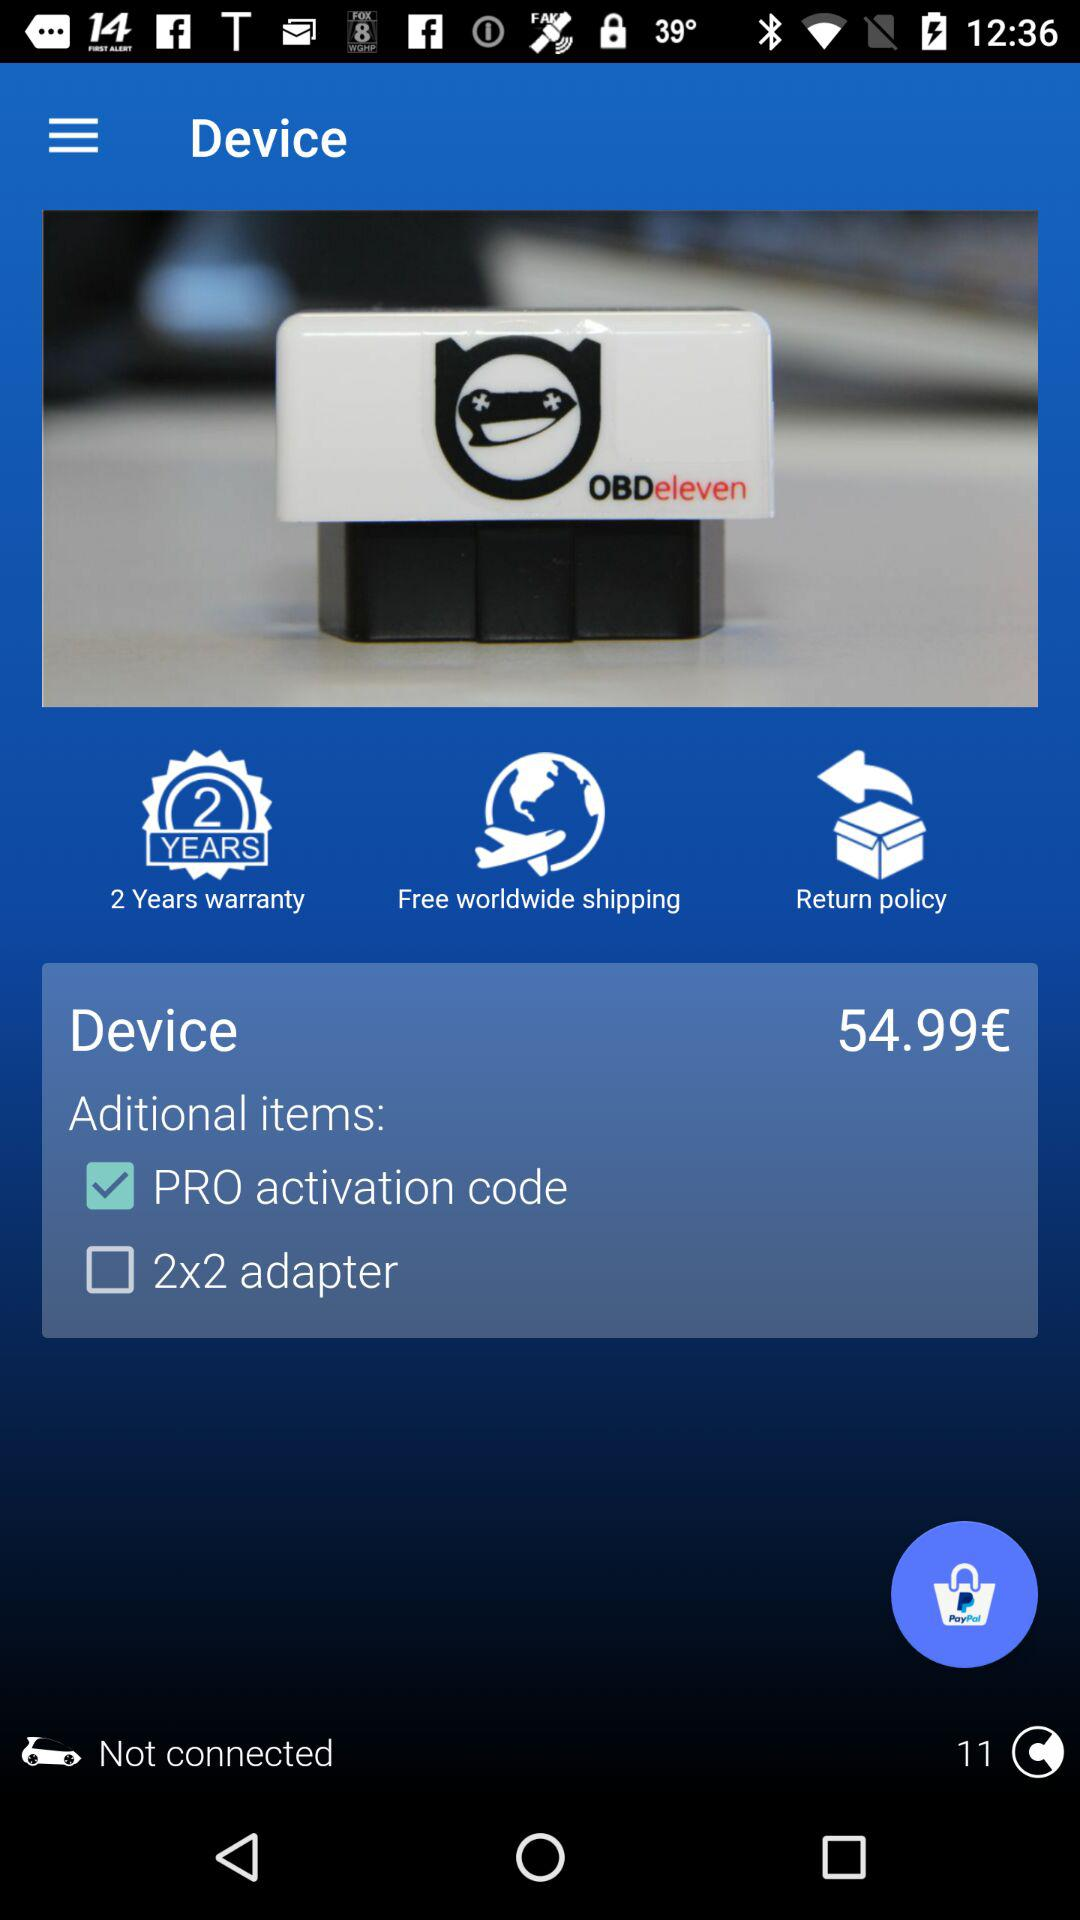What is the status of "2x2 adapter"? The status is "off". 